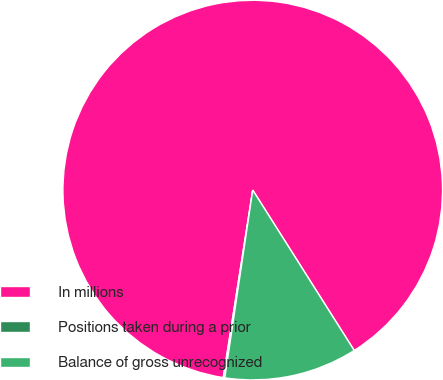Convert chart. <chart><loc_0><loc_0><loc_500><loc_500><pie_chart><fcel>In millions<fcel>Positions taken during a prior<fcel>Balance of gross unrecognized<nl><fcel>88.54%<fcel>0.13%<fcel>11.33%<nl></chart> 